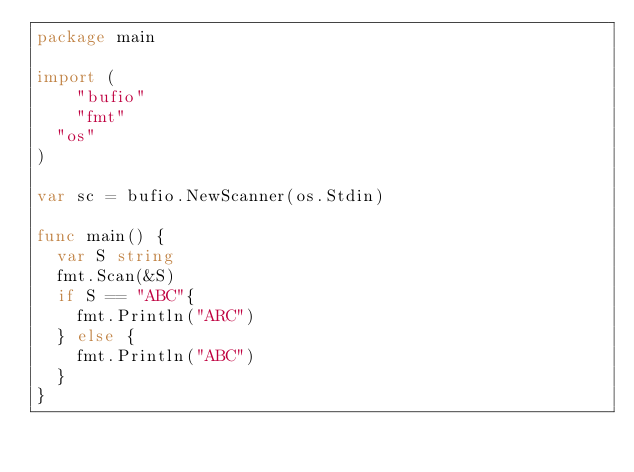<code> <loc_0><loc_0><loc_500><loc_500><_Go_>package main

import (
    "bufio"
    "fmt"
	"os"
)

var sc = bufio.NewScanner(os.Stdin)

func main() {
	var S string
	fmt.Scan(&S)
	if S == "ABC"{
		fmt.Println("ARC")
	} else {
		fmt.Println("ABC")
	}
}</code> 